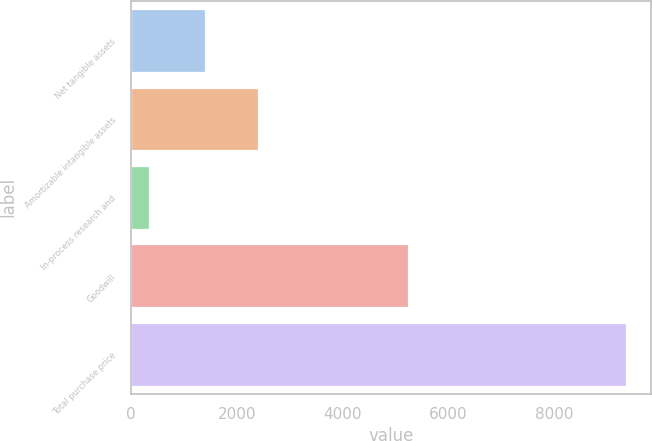Convert chart. <chart><loc_0><loc_0><loc_500><loc_500><bar_chart><fcel>Net tangible assets<fcel>Amortizable intangible assets<fcel>In-process research and<fcel>Goodwill<fcel>Total purchase price<nl><fcel>1400<fcel>2402<fcel>331<fcel>5230<fcel>9363<nl></chart> 